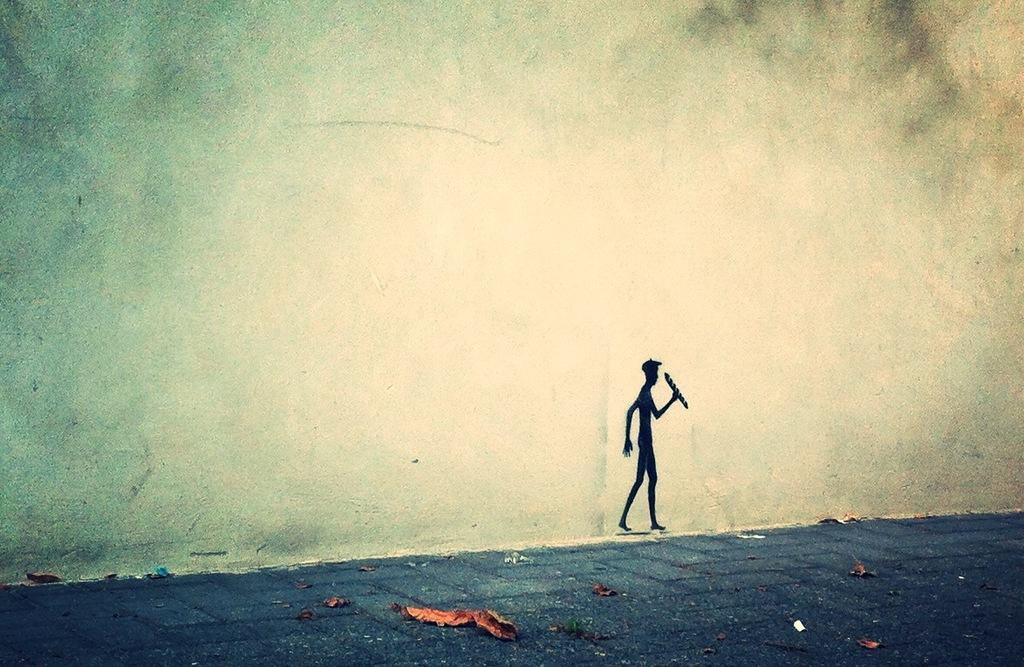Please provide a concise description of this image. In this image we can see the painting of a person on a wall. On the bottom of the image we can see some dried leaves on the ground. 